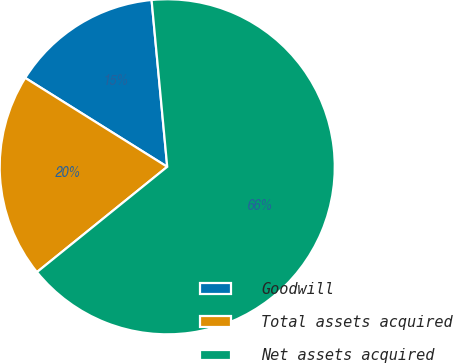Convert chart. <chart><loc_0><loc_0><loc_500><loc_500><pie_chart><fcel>Goodwill<fcel>Total assets acquired<fcel>Net assets acquired<nl><fcel>14.61%<fcel>19.72%<fcel>65.67%<nl></chart> 